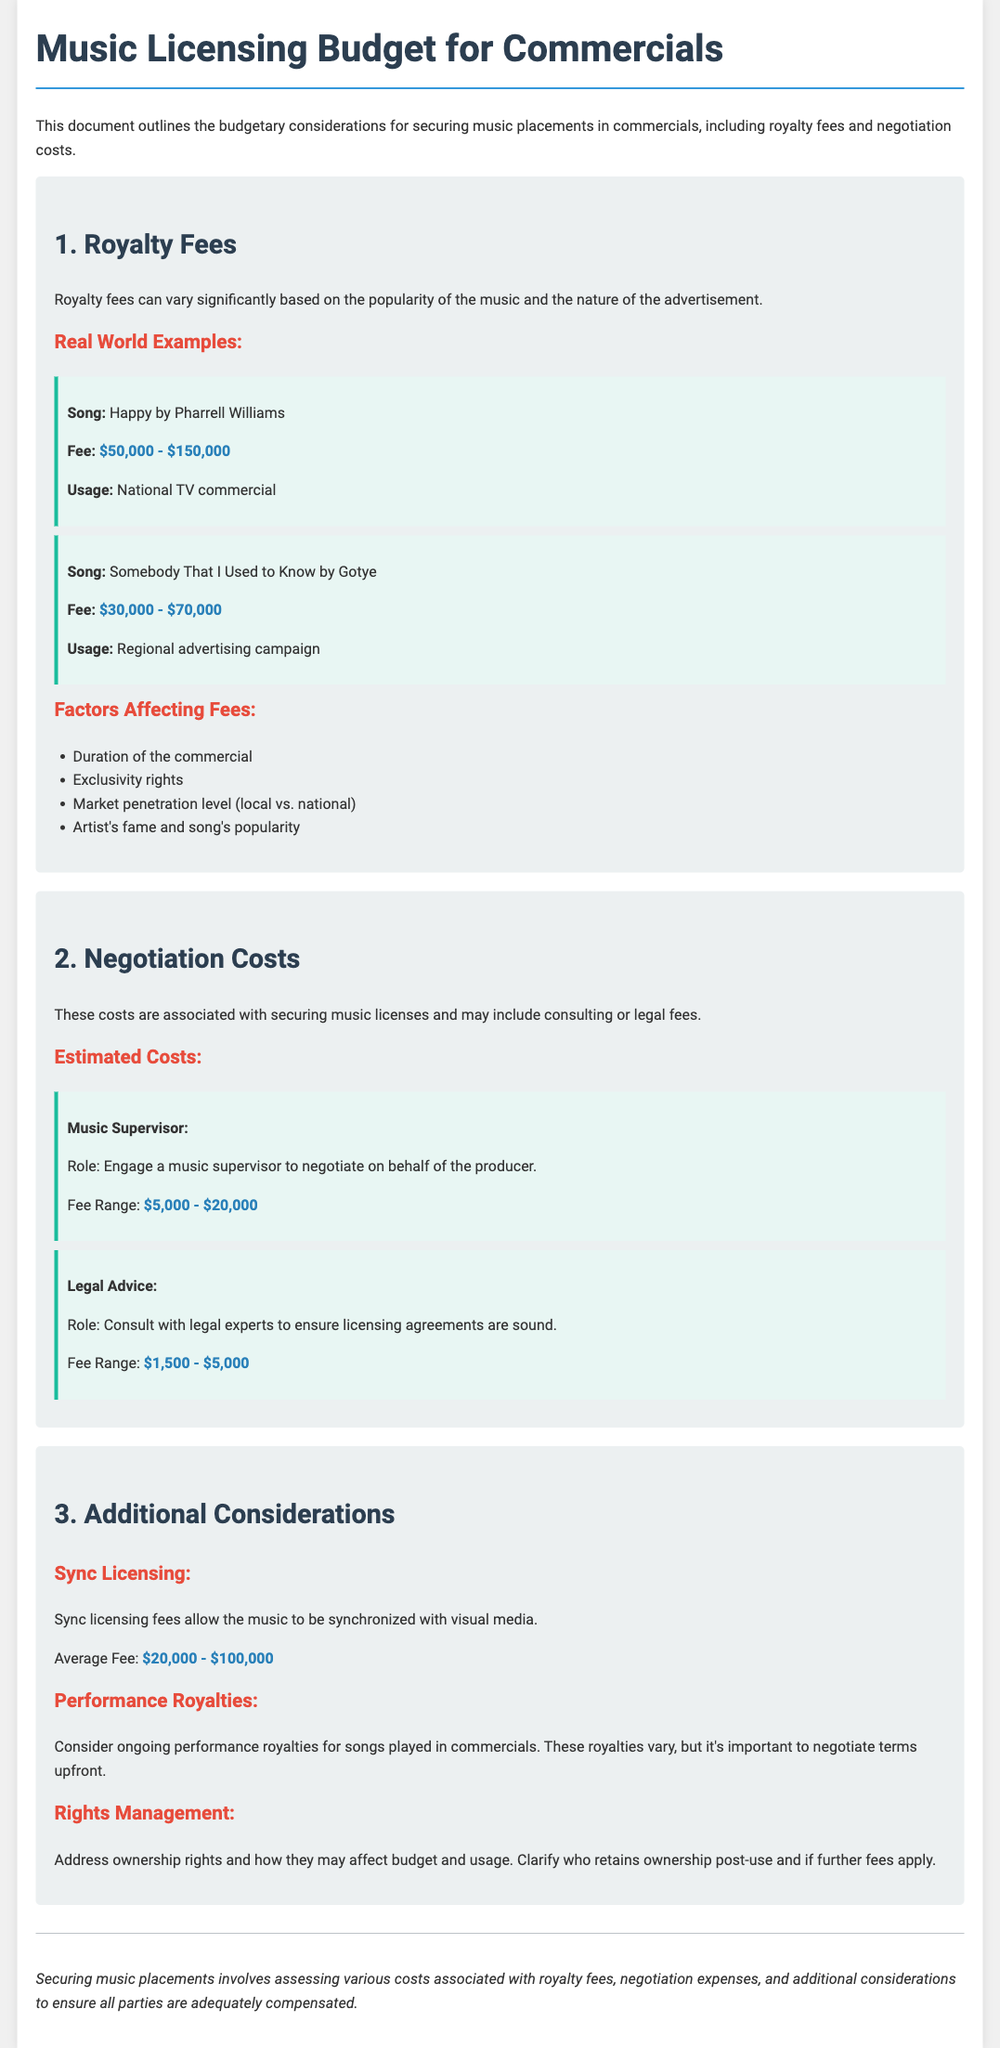What are the fees for "Happy" by Pharrell Williams? The document states the fee for "Happy" is between $50,000 and $150,000.
Answer: $50,000 - $150,000 What is the average fee for Sync Licensing? The document mentions the average fee for Sync Licensing is between $20,000 and $100,000.
Answer: $20,000 - $100,000 What role does a Music Supervisor play? According to the document, a Music Supervisor engages to negotiate on behalf of the producer.
Answer: Engage a music supervisor to negotiate What is the fee range for legal advice? The document specifies the fee range for legal advice as $1,500 to $5,000.
Answer: $1,500 - $5,000 What factors affect royalty fees? The document lists several factors, including duration, exclusivity rights, and artist's fame.
Answer: Duration of the commercial, exclusivity rights, market penetration level, artist's fame and song's popularity What is included in negotiation costs? The document states that negotiation costs may include consulting or legal fees.
Answer: Consulting or legal fees What type of rights management considerations are mentioned? The document discusses ownership rights and their effect on budget and usage.
Answer: Ownership rights What is the usage context for "Somebody That I Used to Know"? The document states its usage was for a regional advertising campaign.
Answer: Regional advertising campaign 